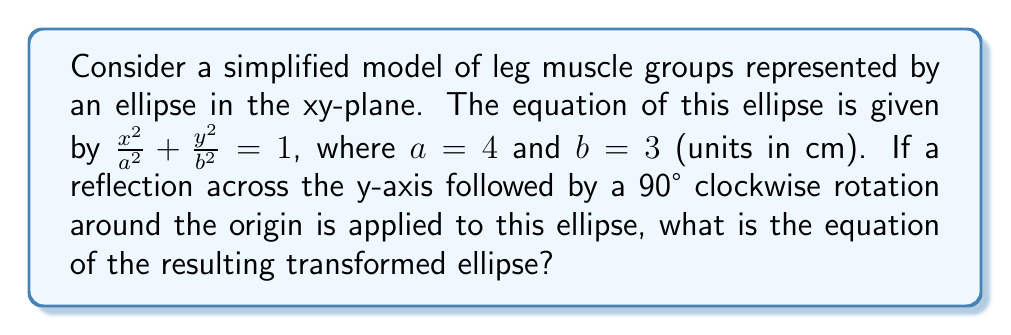What is the answer to this math problem? Let's approach this step-by-step:

1) The original ellipse equation is $\frac{x^2}{4^2} + \frac{y^2}{3^2} = 1$ or $\frac{x^2}{16} + \frac{y^2}{9} = 1$.

2) First, we apply a reflection across the y-axis. This transformation changes x to -x:
   $\frac{(-x)^2}{16} + \frac{y^2}{9} = 1$
   which simplifies to the same equation: $\frac{x^2}{16} + \frac{y^2}{9} = 1$

3) Next, we apply a 90° clockwise rotation around the origin. This transformation can be represented by the following coordinate change:
   $x' = y$ and $y' = -x$

4) Substituting these into our equation:
   $\frac{(-y')^2}{16} + \frac{(x')^2}{9} = 1$

5) Simplifying:
   $\frac{y'^2}{16} + \frac{x'^2}{9} = 1$

6) Rearranging to standard form:
   $\frac{x'^2}{9} + \frac{y'^2}{16} = 1$

7) This is the equation of an ellipse with $a = 3$ and $b = 4$.
Answer: $\frac{x^2}{9} + \frac{y^2}{16} = 1$ 